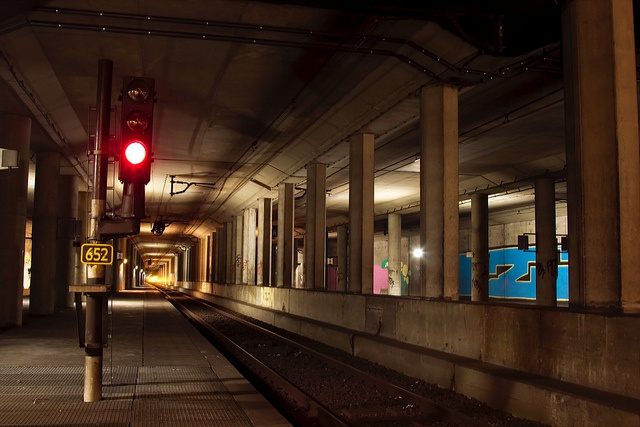Describe the objects in this image and their specific colors. I can see a traffic light in black, maroon, and white tones in this image. 